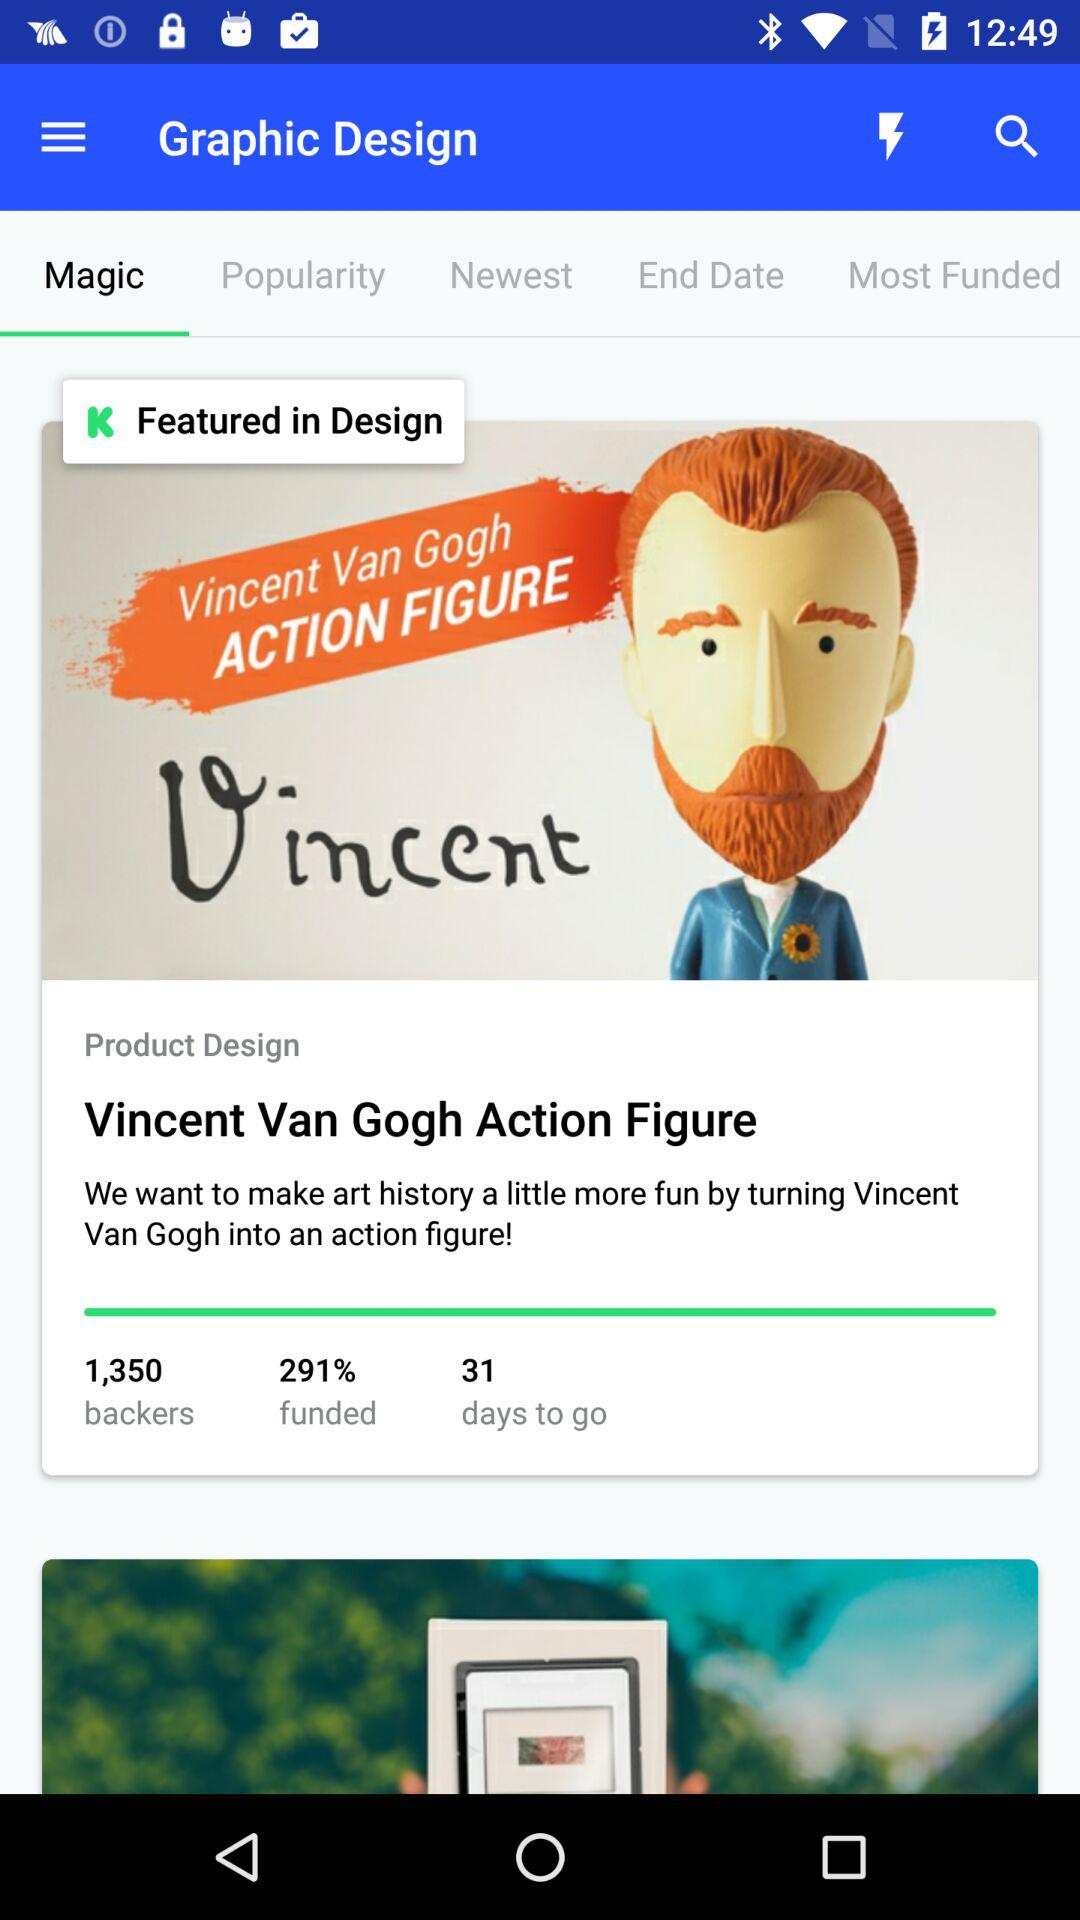What is the number of backers? The number of backers is 1,350. 